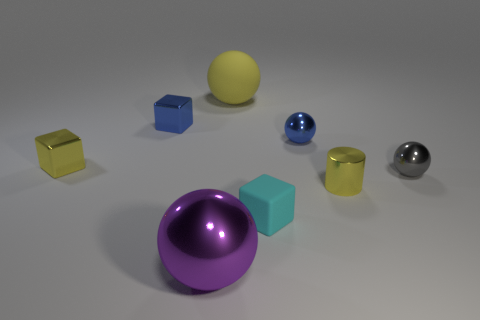Add 1 cyan objects. How many objects exist? 9 Subtract all gray spheres. How many spheres are left? 3 Subtract all purple shiny balls. How many balls are left? 3 Subtract all brown spheres. Subtract all cyan cylinders. How many spheres are left? 4 Subtract all cylinders. How many objects are left? 7 Add 3 small gray metal objects. How many small gray metal objects exist? 4 Subtract 1 purple spheres. How many objects are left? 7 Subtract all tiny rubber blocks. Subtract all gray metallic spheres. How many objects are left? 6 Add 8 purple shiny things. How many purple shiny things are left? 9 